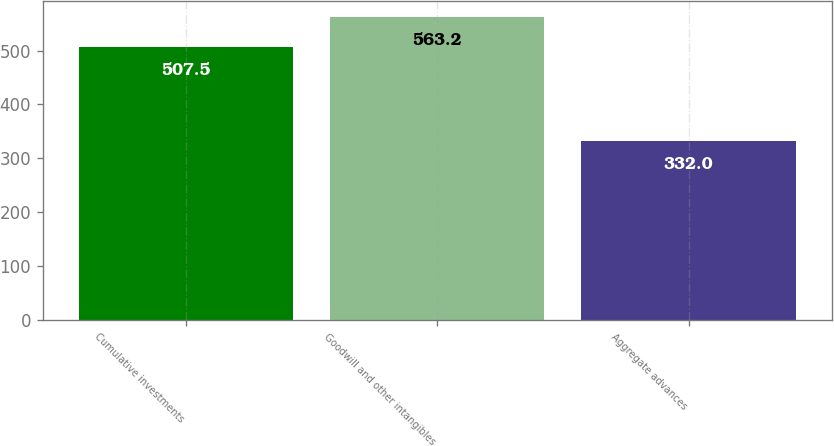Convert chart to OTSL. <chart><loc_0><loc_0><loc_500><loc_500><bar_chart><fcel>Cumulative investments<fcel>Goodwill and other intangibles<fcel>Aggregate advances<nl><fcel>507.5<fcel>563.2<fcel>332<nl></chart> 